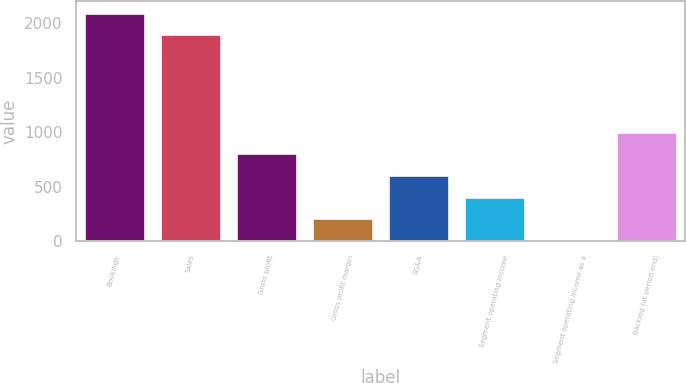Convert chart. <chart><loc_0><loc_0><loc_500><loc_500><bar_chart><fcel>Bookings<fcel>Sales<fcel>Gross profit<fcel>Gross profit margin<fcel>SG&A<fcel>Segment operating income<fcel>Segment operating income as a<fcel>Backlog (at period end)<nl><fcel>2097.62<fcel>1899.2<fcel>804.58<fcel>209.32<fcel>606.16<fcel>407.74<fcel>10.9<fcel>1003<nl></chart> 